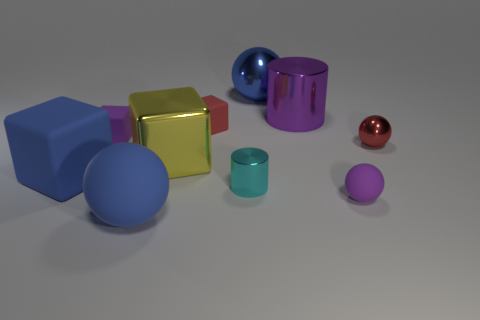Subtract all big blue matte cubes. How many cubes are left? 3 Subtract all purple spheres. How many spheres are left? 3 Subtract all cylinders. How many objects are left? 8 Subtract all cyan objects. Subtract all purple cylinders. How many objects are left? 8 Add 7 big blue blocks. How many big blue blocks are left? 8 Add 2 balls. How many balls exist? 6 Subtract 0 cyan blocks. How many objects are left? 10 Subtract 2 balls. How many balls are left? 2 Subtract all yellow balls. Subtract all brown cylinders. How many balls are left? 4 Subtract all purple cubes. How many brown cylinders are left? 0 